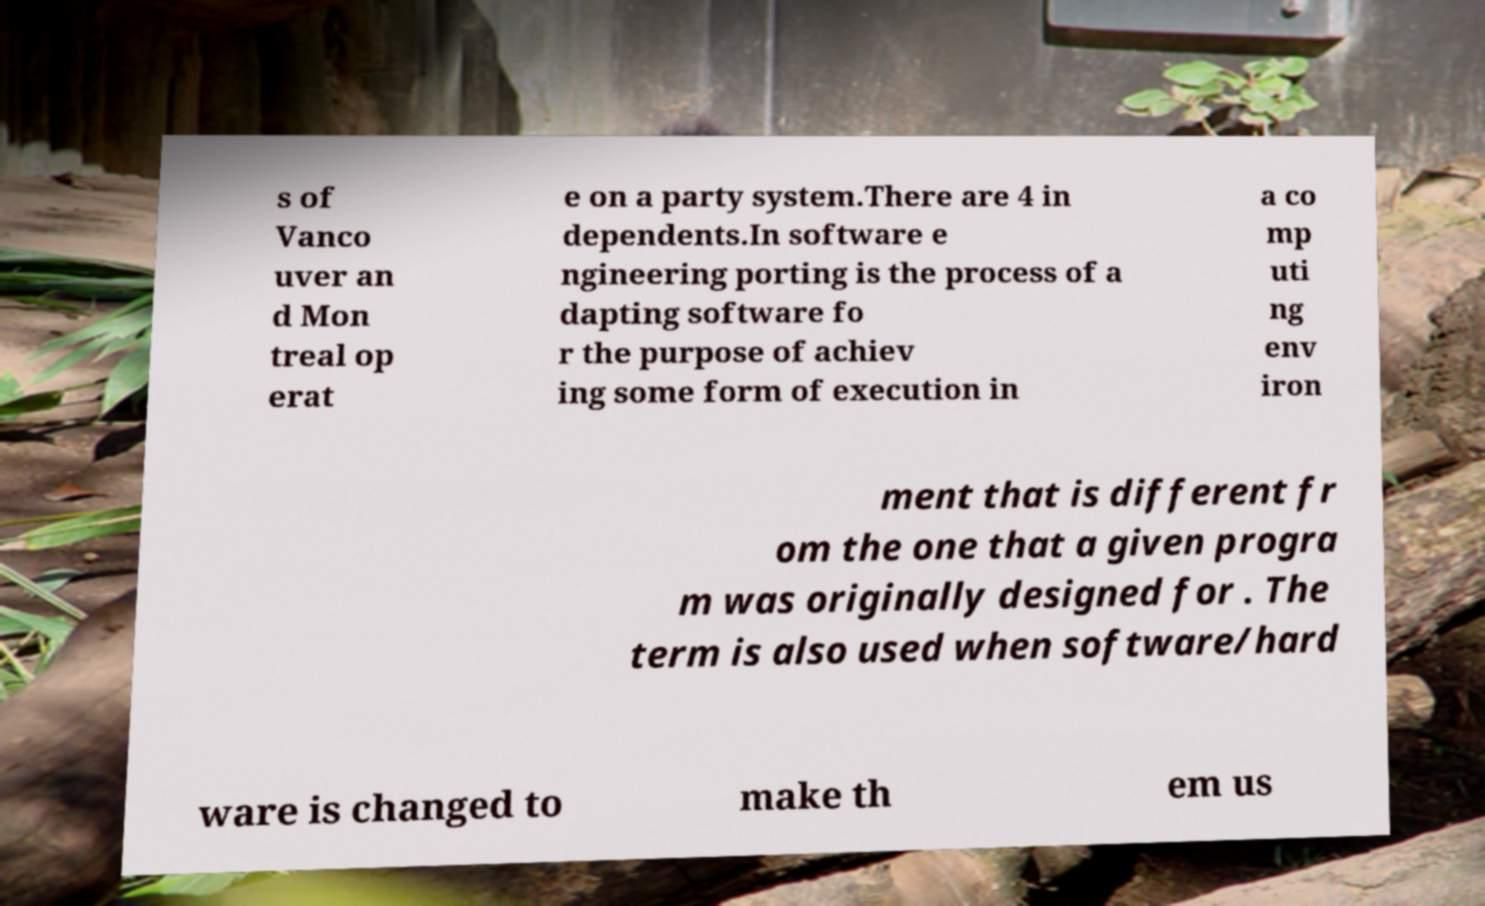Could you assist in decoding the text presented in this image and type it out clearly? s of Vanco uver an d Mon treal op erat e on a party system.There are 4 in dependents.In software e ngineering porting is the process of a dapting software fo r the purpose of achiev ing some form of execution in a co mp uti ng env iron ment that is different fr om the one that a given progra m was originally designed for . The term is also used when software/hard ware is changed to make th em us 